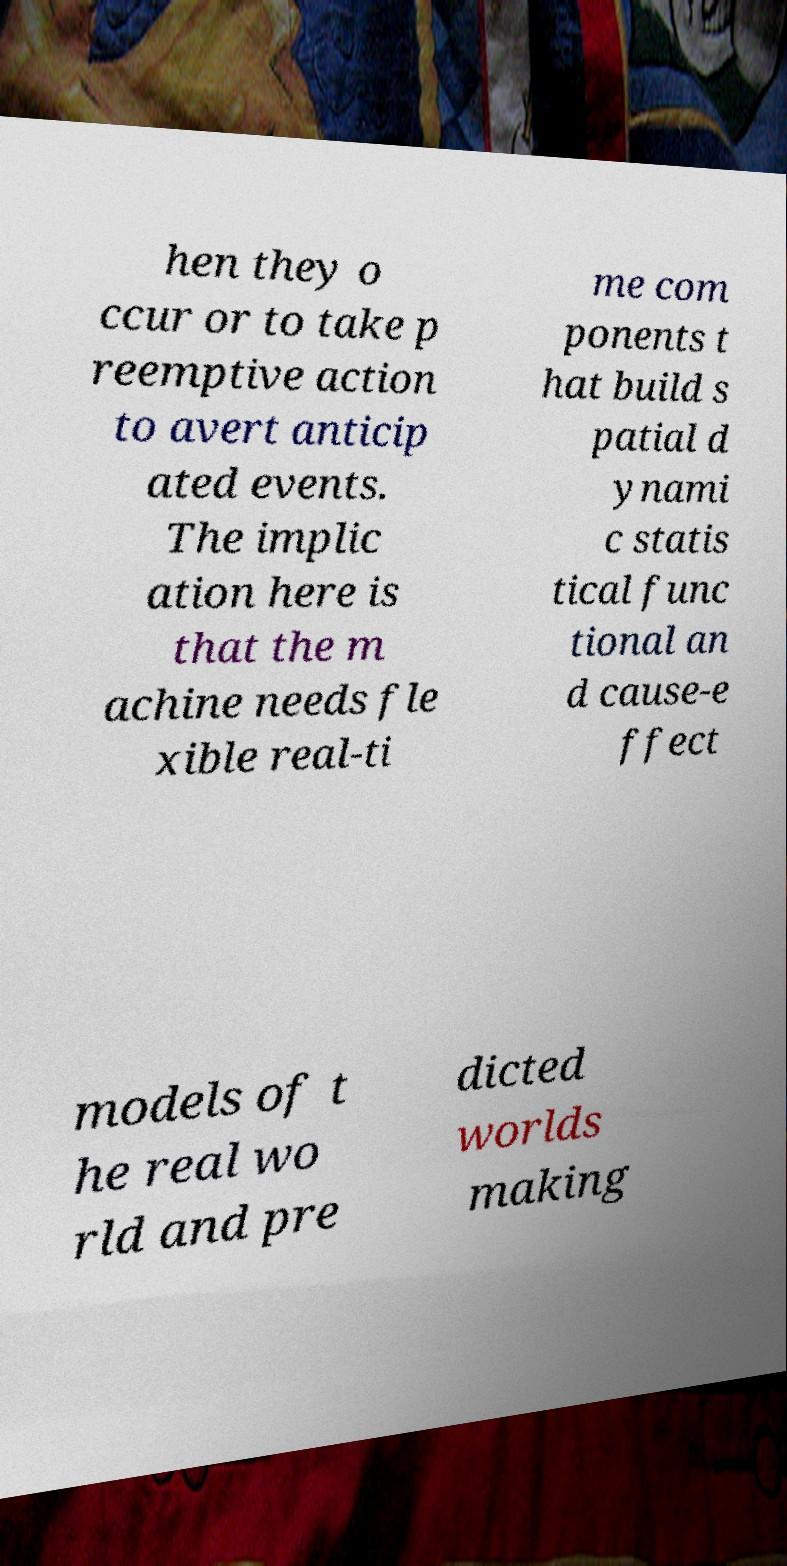Please identify and transcribe the text found in this image. hen they o ccur or to take p reemptive action to avert anticip ated events. The implic ation here is that the m achine needs fle xible real-ti me com ponents t hat build s patial d ynami c statis tical func tional an d cause-e ffect models of t he real wo rld and pre dicted worlds making 